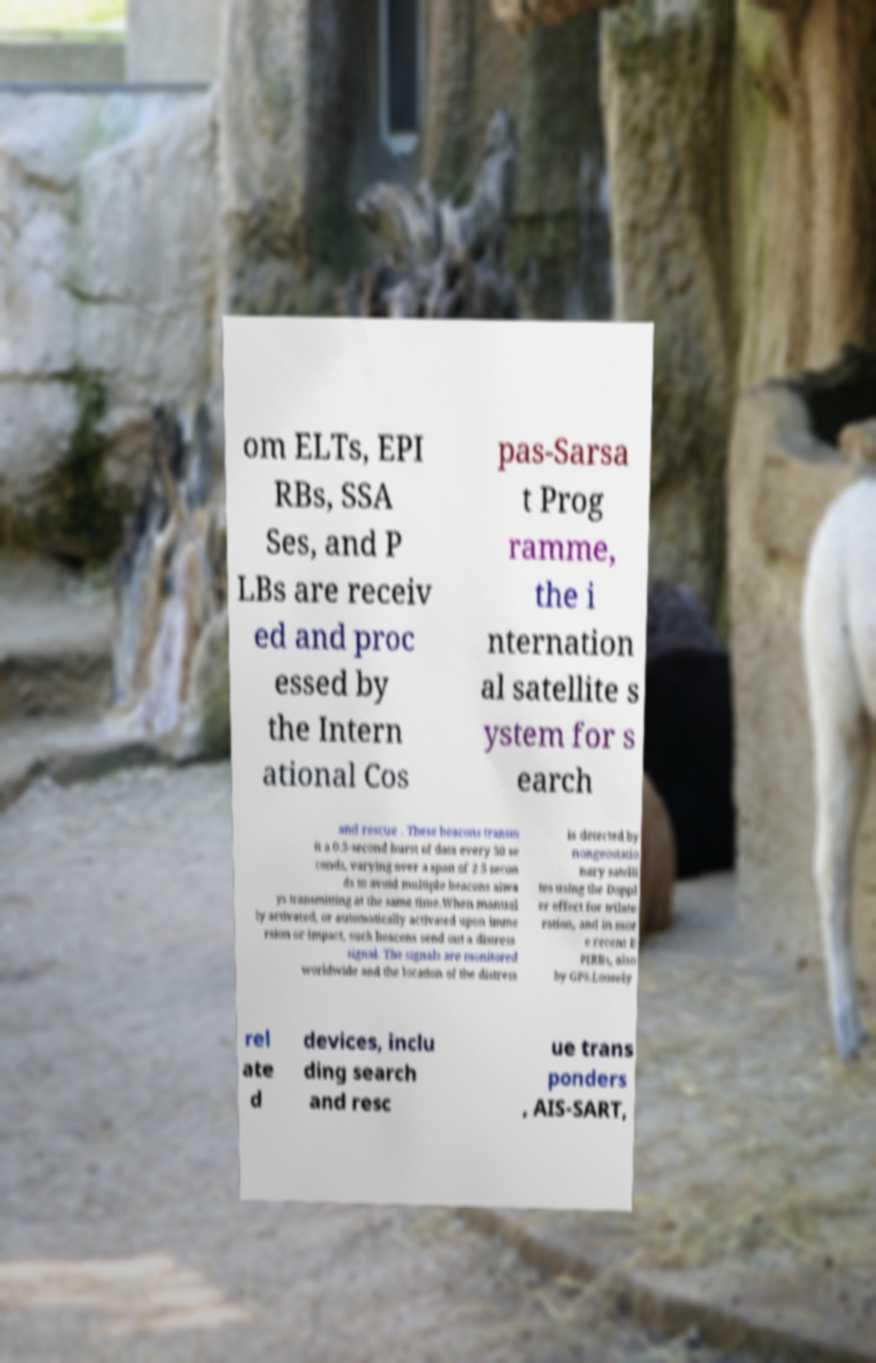For documentation purposes, I need the text within this image transcribed. Could you provide that? om ELTs, EPI RBs, SSA Ses, and P LBs are receiv ed and proc essed by the Intern ational Cos pas-Sarsa t Prog ramme, the i nternation al satellite s ystem for s earch and rescue . These beacons transm it a 0.5-second burst of data every 50 se conds, varying over a span of 2.5 secon ds to avoid multiple beacons alwa ys transmitting at the same time.When manual ly activated, or automatically activated upon imme rsion or impact, such beacons send out a distress signal. The signals are monitored worldwide and the location of the distress is detected by nongeostatio nary satelli tes using the Doppl er effect for trilate ration, and in mor e recent E PIRBs, also by GPS.Loosely rel ate d devices, inclu ding search and resc ue trans ponders , AIS-SART, 